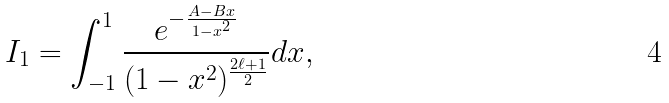<formula> <loc_0><loc_0><loc_500><loc_500>I _ { 1 } = \int _ { - 1 } ^ { 1 } \frac { e ^ { - \frac { A - B x } { 1 - x ^ { 2 } } } } { ( 1 - x ^ { 2 } ) ^ { \frac { 2 \ell + 1 } { 2 } } } d x ,</formula> 